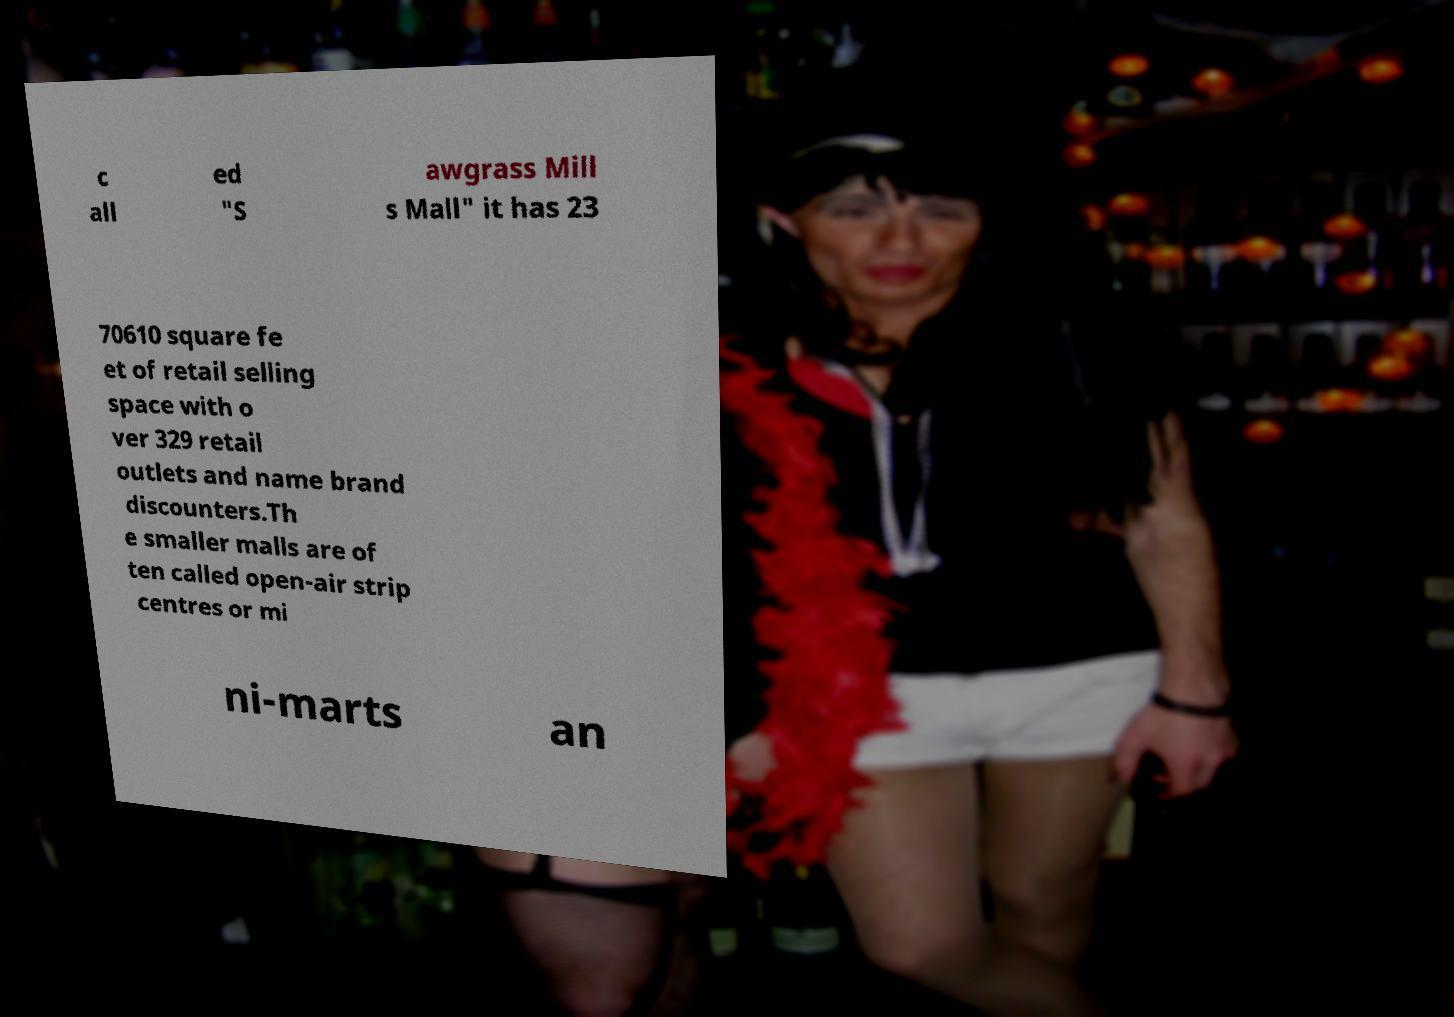I need the written content from this picture converted into text. Can you do that? c all ed "S awgrass Mill s Mall" it has 23 70610 square fe et of retail selling space with o ver 329 retail outlets and name brand discounters.Th e smaller malls are of ten called open-air strip centres or mi ni-marts an 